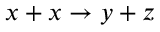<formula> <loc_0><loc_0><loc_500><loc_500>x + x \rightarrow y + z</formula> 